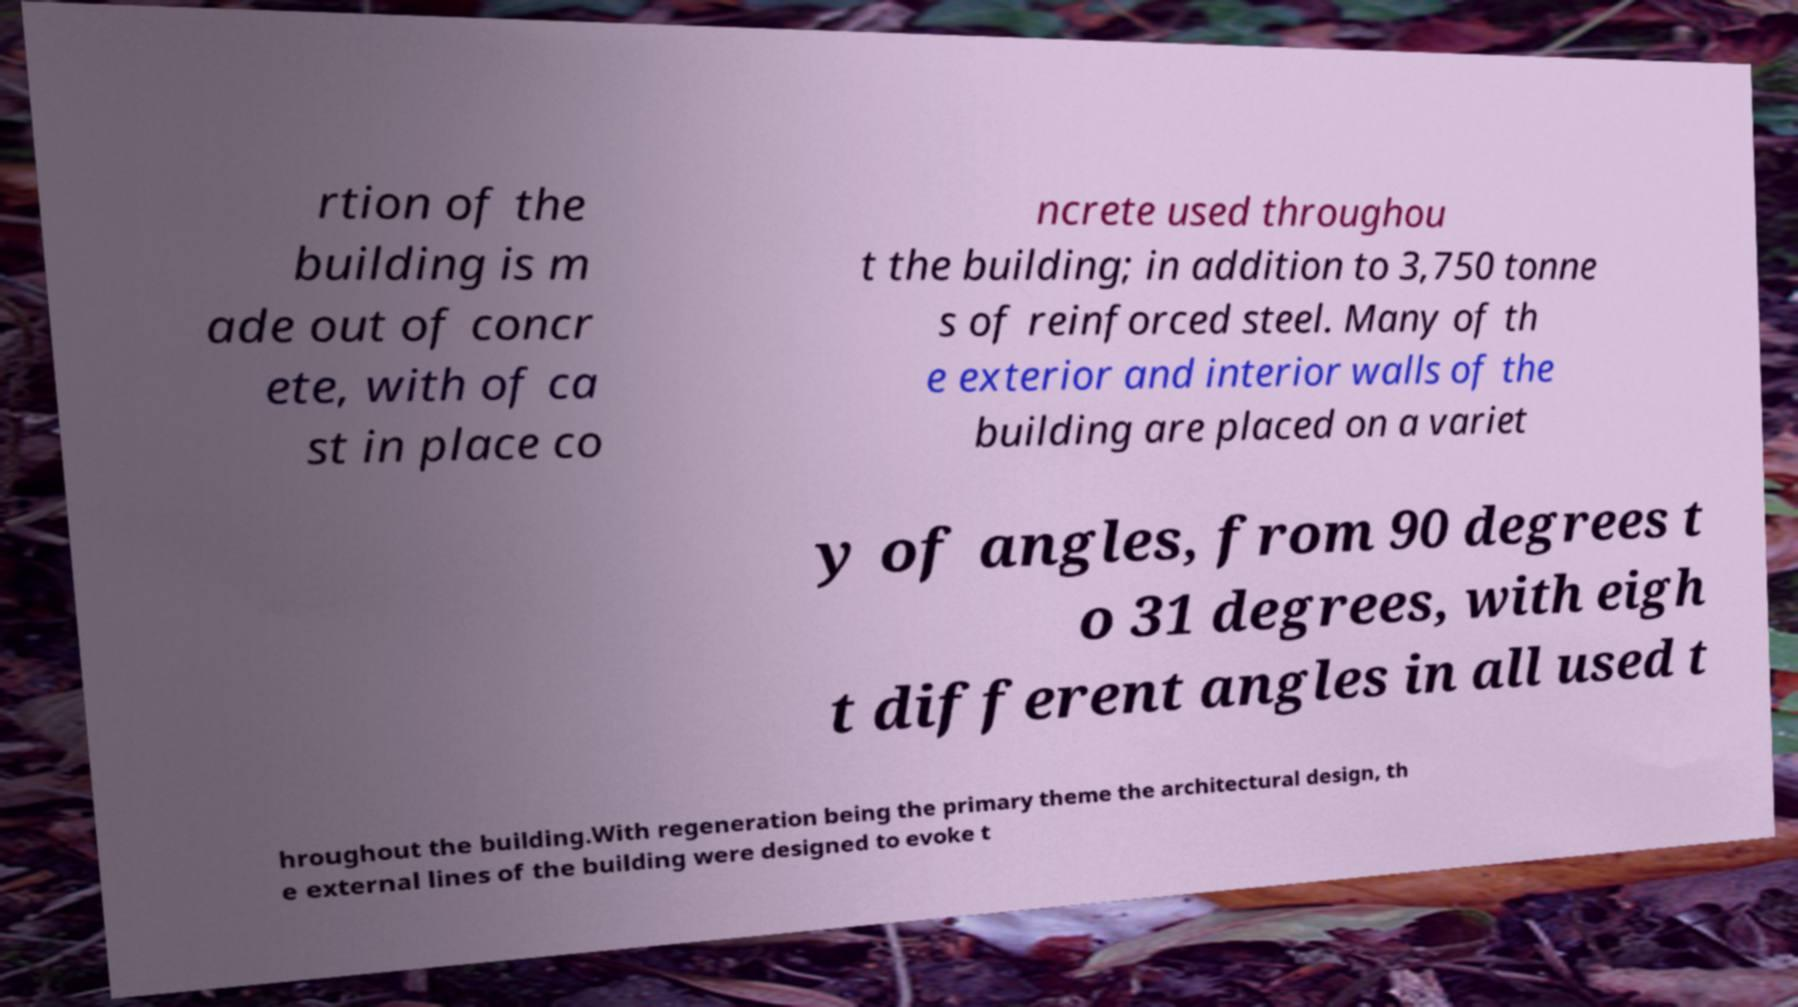Please identify and transcribe the text found in this image. rtion of the building is m ade out of concr ete, with of ca st in place co ncrete used throughou t the building; in addition to 3,750 tonne s of reinforced steel. Many of th e exterior and interior walls of the building are placed on a variet y of angles, from 90 degrees t o 31 degrees, with eigh t different angles in all used t hroughout the building.With regeneration being the primary theme the architectural design, th e external lines of the building were designed to evoke t 